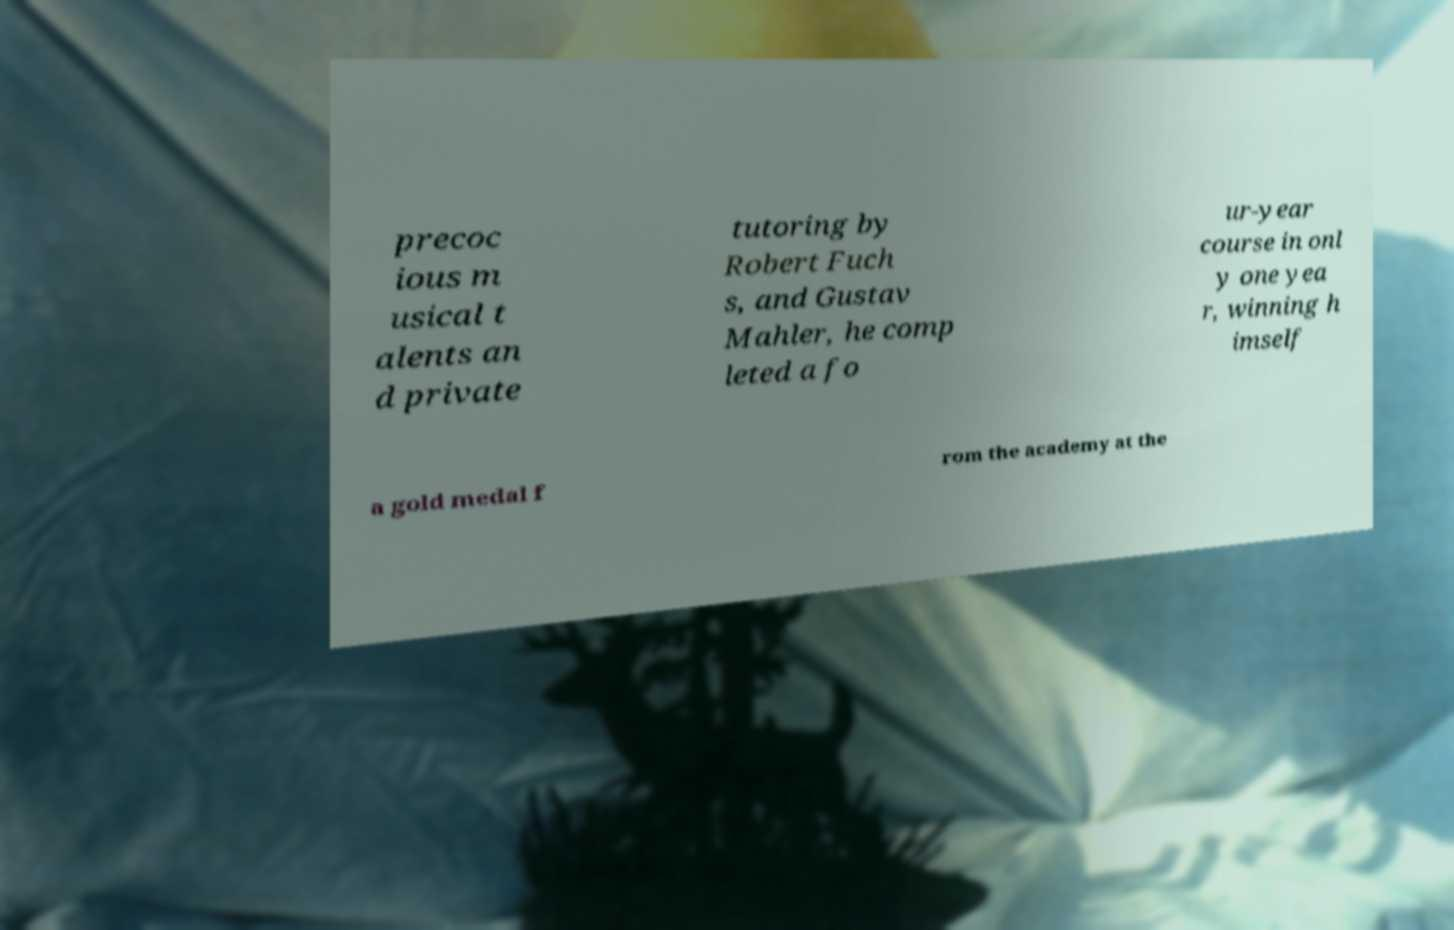Can you accurately transcribe the text from the provided image for me? precoc ious m usical t alents an d private tutoring by Robert Fuch s, and Gustav Mahler, he comp leted a fo ur-year course in onl y one yea r, winning h imself a gold medal f rom the academy at the 